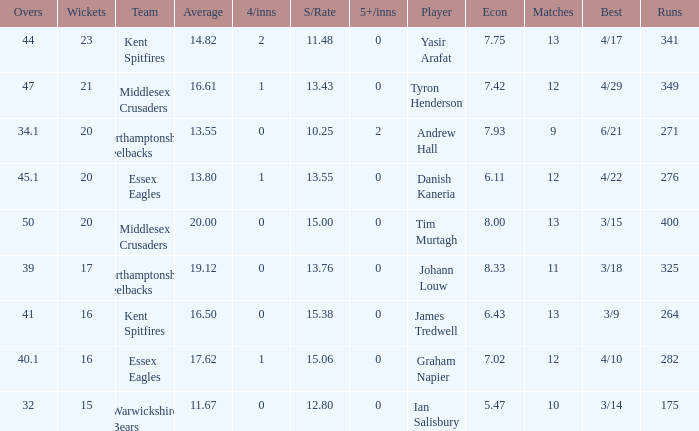Name the matches for wickets 17 11.0. Could you help me parse every detail presented in this table? {'header': ['Overs', 'Wickets', 'Team', 'Average', '4/inns', 'S/Rate', '5+/inns', 'Player', 'Econ', 'Matches', 'Best', 'Runs'], 'rows': [['44', '23', 'Kent Spitfires', '14.82', '2', '11.48', '0', 'Yasir Arafat', '7.75', '13', '4/17', '341'], ['47', '21', 'Middlesex Crusaders', '16.61', '1', '13.43', '0', 'Tyron Henderson', '7.42', '12', '4/29', '349'], ['34.1', '20', 'Northamptonshire Steelbacks', '13.55', '0', '10.25', '2', 'Andrew Hall', '7.93', '9', '6/21', '271'], ['45.1', '20', 'Essex Eagles', '13.80', '1', '13.55', '0', 'Danish Kaneria', '6.11', '12', '4/22', '276'], ['50', '20', 'Middlesex Crusaders', '20.00', '0', '15.00', '0', 'Tim Murtagh', '8.00', '13', '3/15', '400'], ['39', '17', 'Northamptonshire Steelbacks', '19.12', '0', '13.76', '0', 'Johann Louw', '8.33', '11', '3/18', '325'], ['41', '16', 'Kent Spitfires', '16.50', '0', '15.38', '0', 'James Tredwell', '6.43', '13', '3/9', '264'], ['40.1', '16', 'Essex Eagles', '17.62', '1', '15.06', '0', 'Graham Napier', '7.02', '12', '4/10', '282'], ['32', '15', 'Warwickshire Bears', '11.67', '0', '12.80', '0', 'Ian Salisbury', '5.47', '10', '3/14', '175']]} 